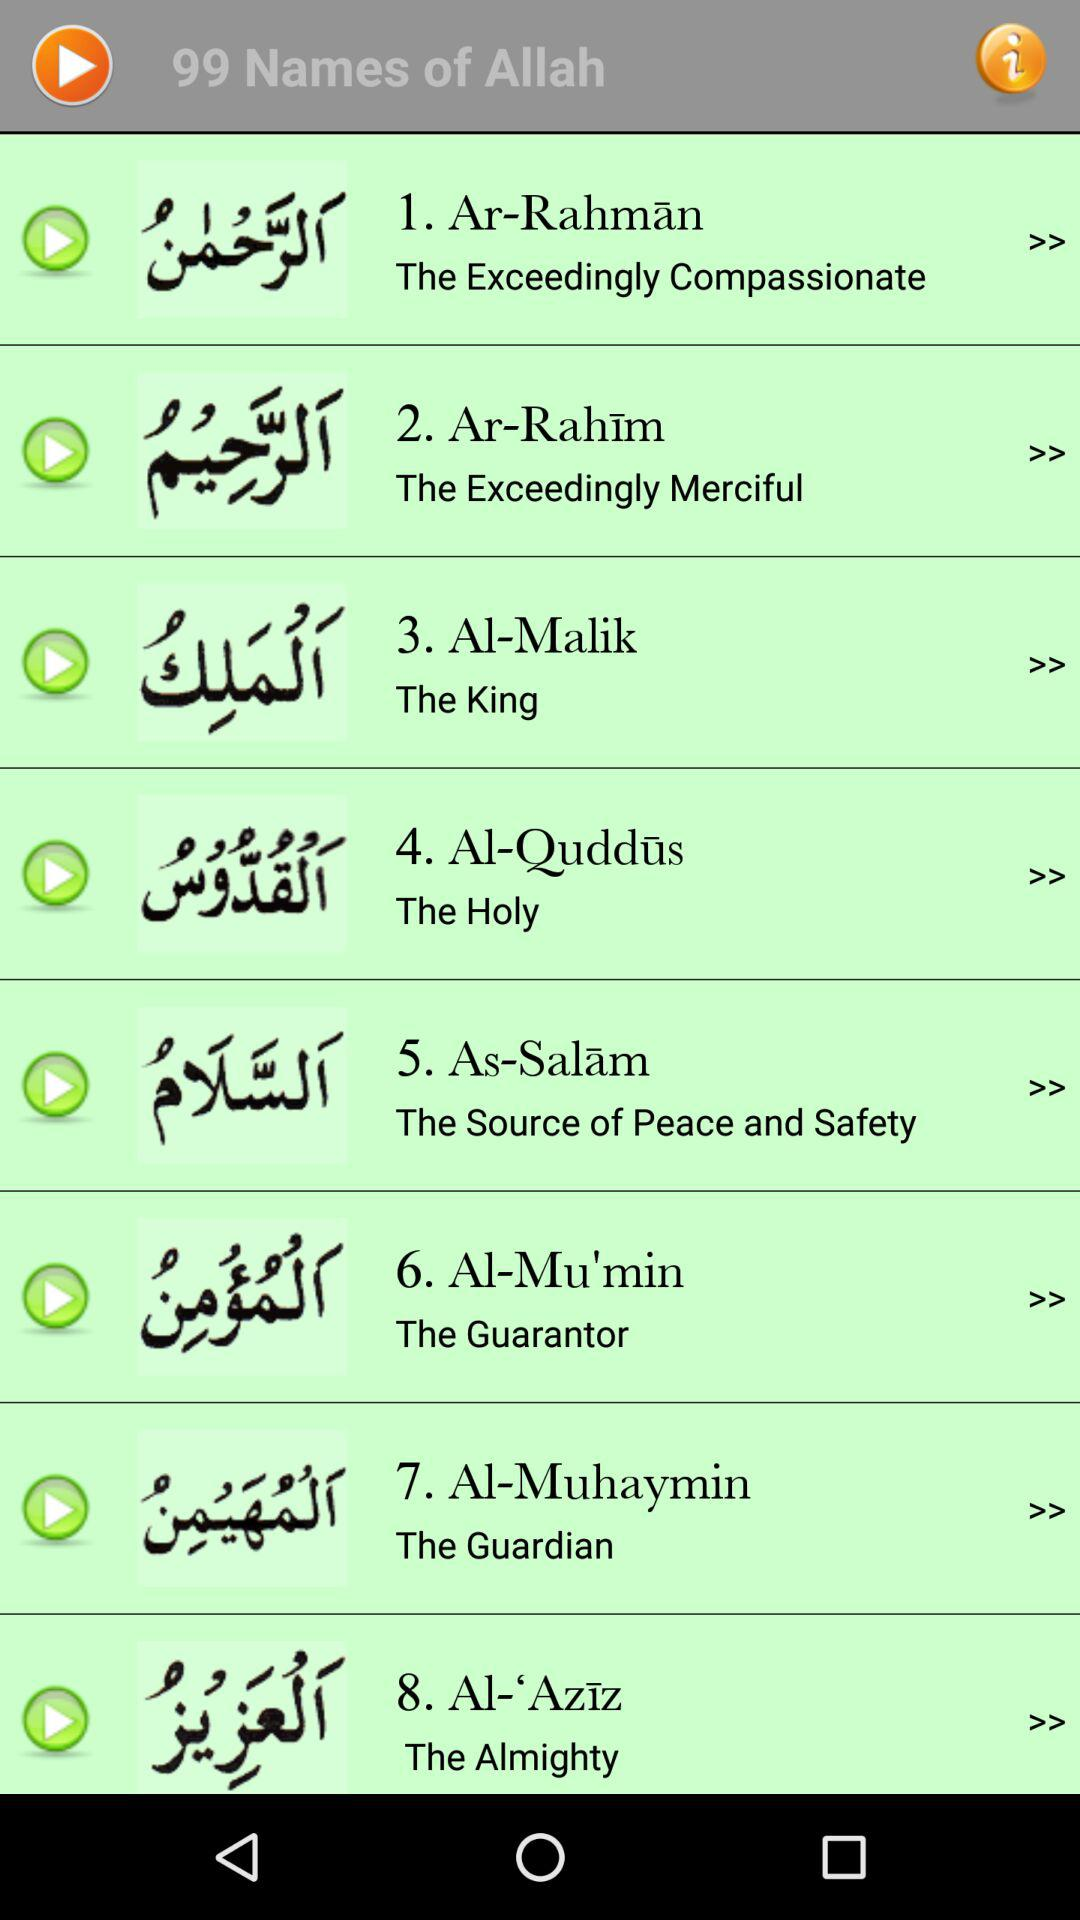How many names of Allah are there? There are 99 names of Allah. 